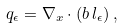<formula> <loc_0><loc_0><loc_500><loc_500>q _ { \epsilon } = \nabla _ { x } \cdot ( b \, l _ { \epsilon } ) \, ,</formula> 